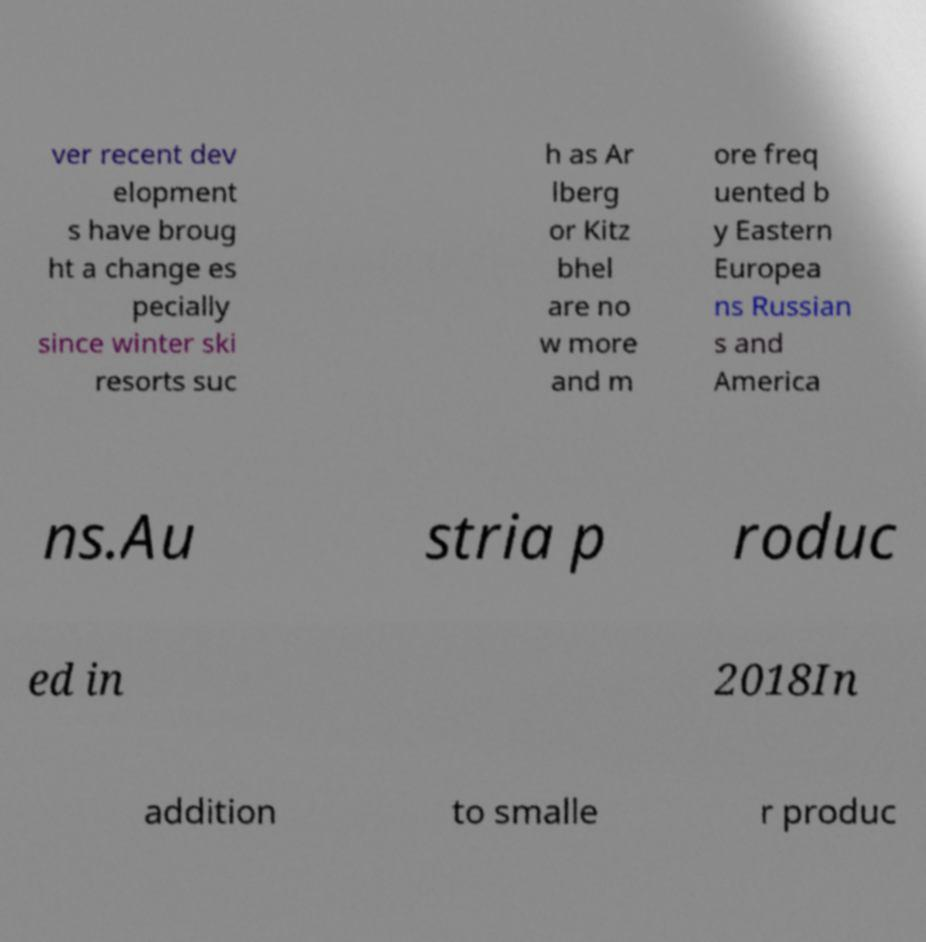Could you extract and type out the text from this image? ver recent dev elopment s have broug ht a change es pecially since winter ski resorts suc h as Ar lberg or Kitz bhel are no w more and m ore freq uented b y Eastern Europea ns Russian s and America ns.Au stria p roduc ed in 2018In addition to smalle r produc 